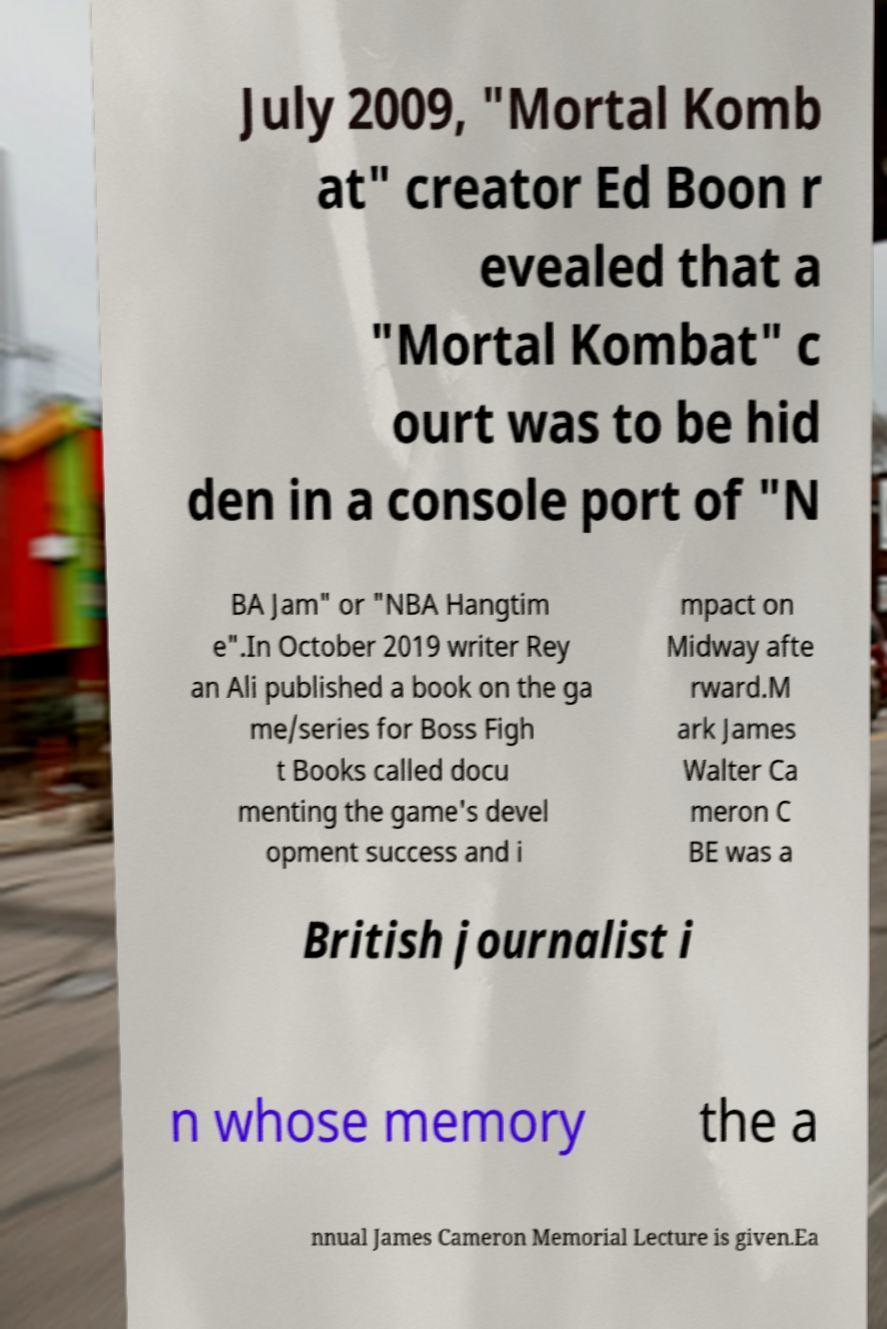Can you read and provide the text displayed in the image?This photo seems to have some interesting text. Can you extract and type it out for me? July 2009, "Mortal Komb at" creator Ed Boon r evealed that a "Mortal Kombat" c ourt was to be hid den in a console port of "N BA Jam" or "NBA Hangtim e".In October 2019 writer Rey an Ali published a book on the ga me/series for Boss Figh t Books called docu menting the game's devel opment success and i mpact on Midway afte rward.M ark James Walter Ca meron C BE was a British journalist i n whose memory the a nnual James Cameron Memorial Lecture is given.Ea 